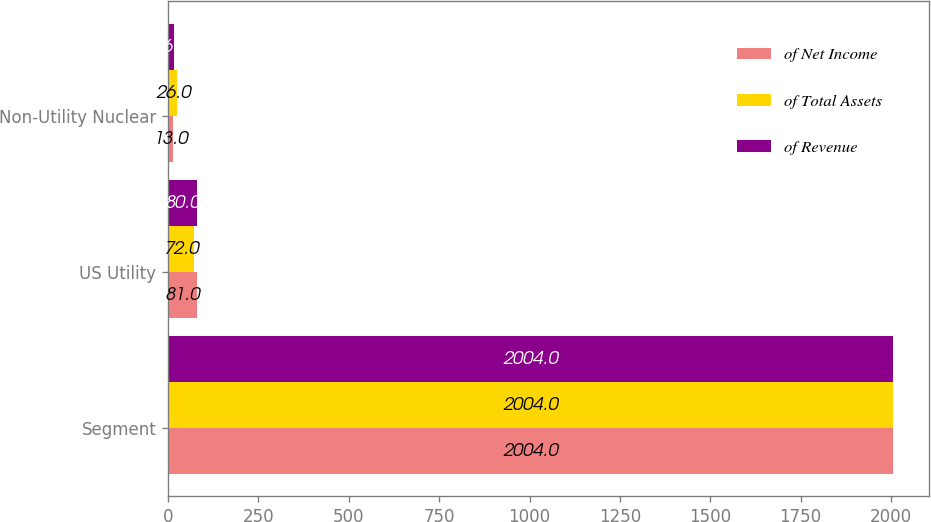<chart> <loc_0><loc_0><loc_500><loc_500><stacked_bar_chart><ecel><fcel>Segment<fcel>US Utility<fcel>Non-Utility Nuclear<nl><fcel>of Net Income<fcel>2004<fcel>81<fcel>13<nl><fcel>of Total Assets<fcel>2004<fcel>72<fcel>26<nl><fcel>of Revenue<fcel>2004<fcel>80<fcel>16<nl></chart> 